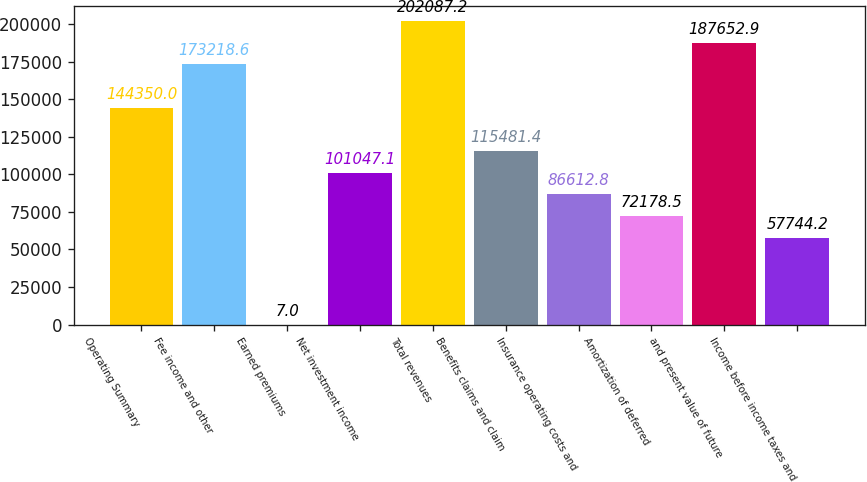Convert chart. <chart><loc_0><loc_0><loc_500><loc_500><bar_chart><fcel>Operating Summary<fcel>Fee income and other<fcel>Earned premiums<fcel>Net investment income<fcel>Total revenues<fcel>Benefits claims and claim<fcel>Insurance operating costs and<fcel>Amortization of deferred<fcel>and present value of future<fcel>Income before income taxes and<nl><fcel>144350<fcel>173219<fcel>7<fcel>101047<fcel>202087<fcel>115481<fcel>86612.8<fcel>72178.5<fcel>187653<fcel>57744.2<nl></chart> 